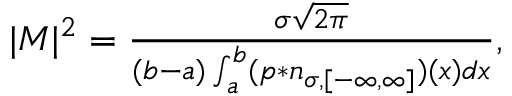<formula> <loc_0><loc_0><loc_500><loc_500>\begin{array} { r } { | M | ^ { 2 } = \frac { \sigma \sqrt { 2 \pi } } { ( b - a ) \int _ { a } ^ { b } ( p \ast n _ { \sigma , [ - \infty , \infty ] } ) ( x ) d x } , } \end{array}</formula> 